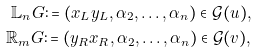<formula> <loc_0><loc_0><loc_500><loc_500>\mathbb { L } _ { n } G \colon = ( x _ { L } y _ { L } , \alpha _ { 2 } , \dots , \alpha _ { n } ) \in \mathcal { G } ( u ) , \\ \mathbb { R } _ { m } G \colon = ( y _ { R } x _ { R } , \alpha _ { 2 } , \dots , \alpha _ { n } ) \in \mathcal { G } ( v ) ,</formula> 